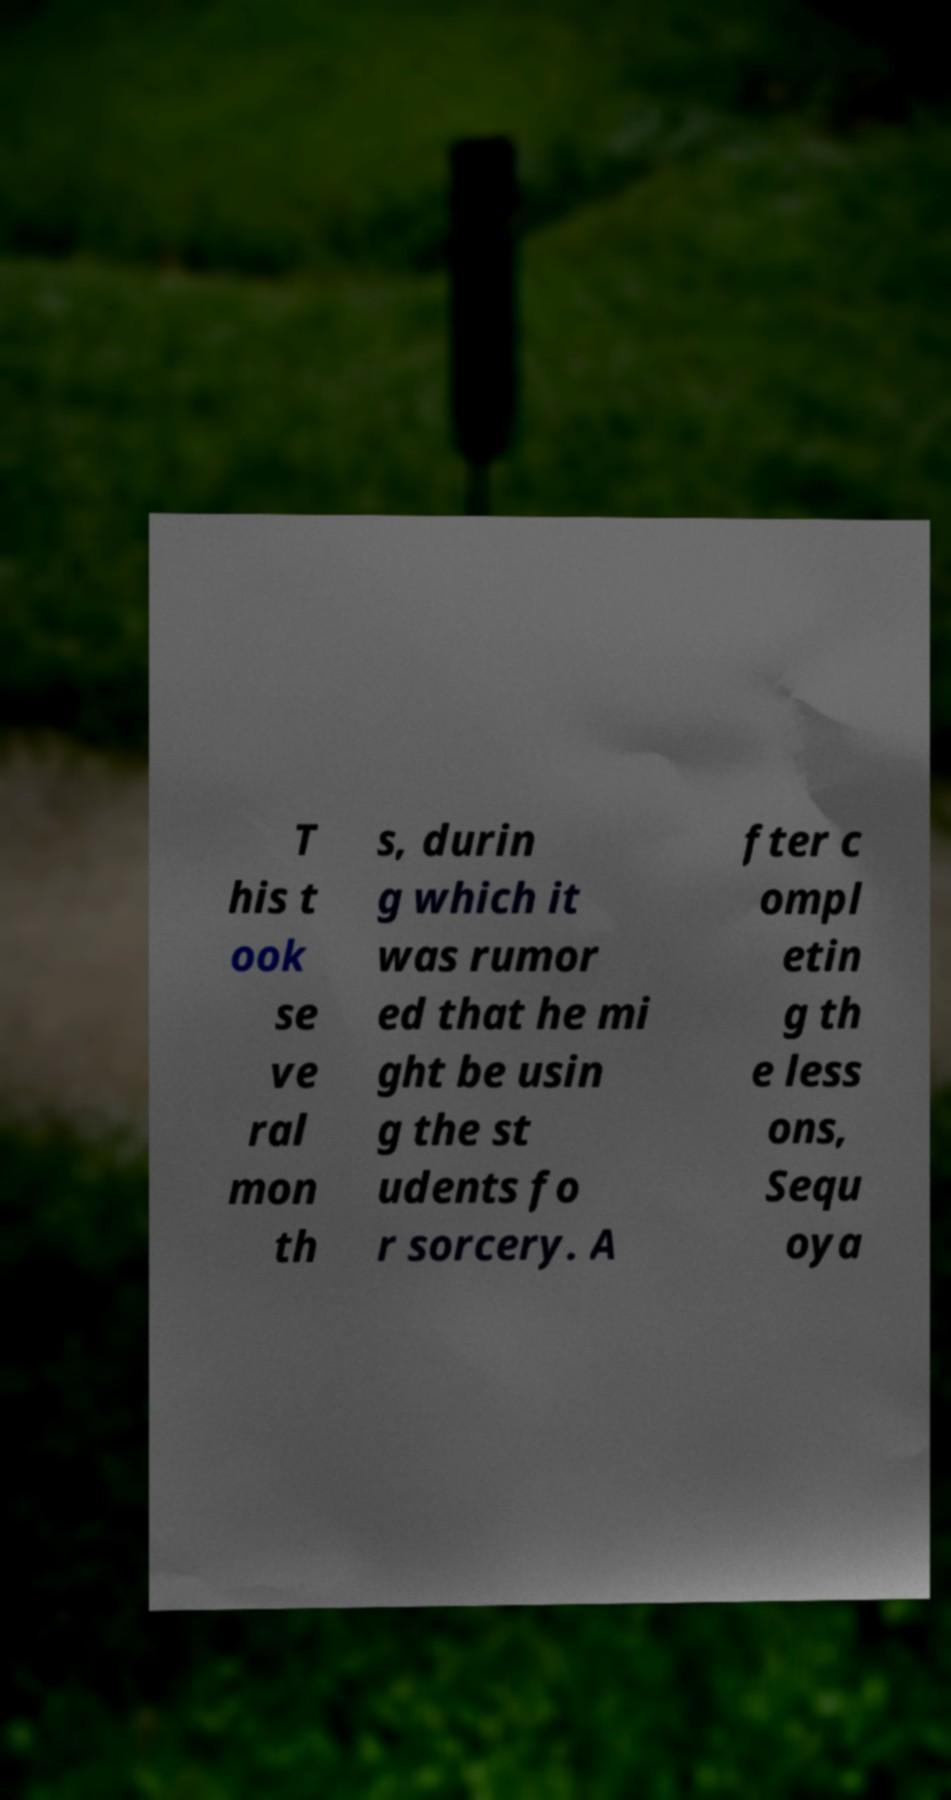Could you extract and type out the text from this image? T his t ook se ve ral mon th s, durin g which it was rumor ed that he mi ght be usin g the st udents fo r sorcery. A fter c ompl etin g th e less ons, Sequ oya 